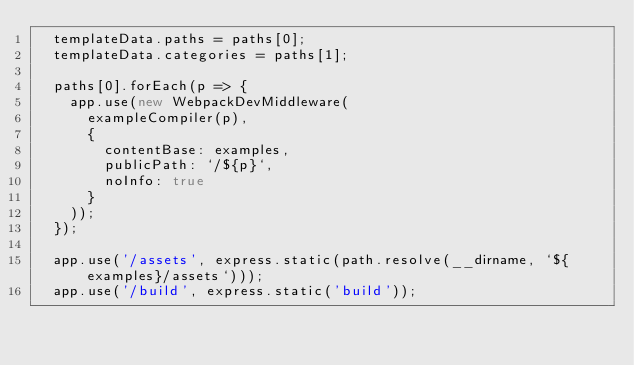Convert code to text. <code><loc_0><loc_0><loc_500><loc_500><_JavaScript_>  templateData.paths = paths[0];
  templateData.categories = paths[1];

  paths[0].forEach(p => {
    app.use(new WebpackDevMiddleware(
      exampleCompiler(p),
      {
        contentBase: examples,
        publicPath: `/${p}`,
        noInfo: true
      }
    ));
  });

  app.use('/assets', express.static(path.resolve(__dirname, `${examples}/assets`)));
  app.use('/build', express.static('build'));</code> 